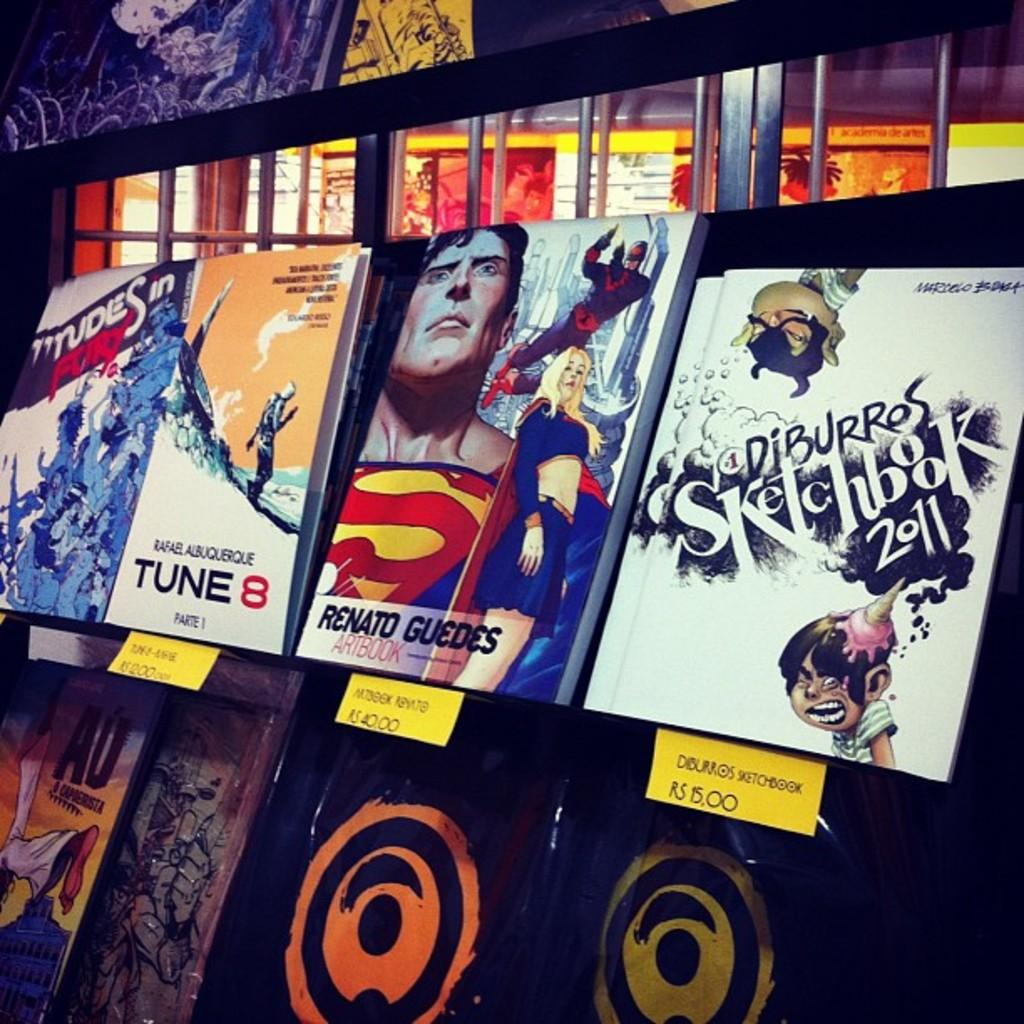<image>
Summarize the visual content of the image. Some of the movies selections include that of Tune 8. 